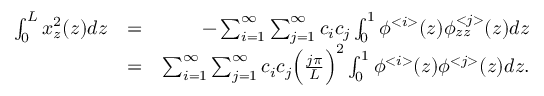Convert formula to latex. <formula><loc_0><loc_0><loc_500><loc_500>\begin{array} { r l r } { \int _ { 0 } ^ { L } x _ { z } ^ { 2 } ( z ) d z } & { = } & { - \sum _ { i = 1 } ^ { \infty } \sum _ { j = 1 } ^ { \infty } c _ { i } c _ { j } \int _ { 0 } ^ { 1 } \phi ^ { < i > } ( z ) \phi _ { z z } ^ { < j > } ( z ) d z } \\ & { = } & { \sum _ { i = 1 } ^ { \infty } \sum _ { j = 1 } ^ { \infty } c _ { i } c _ { j } \left ( \frac { j \pi } { L } \right ) ^ { 2 } \int _ { 0 } ^ { 1 } \phi ^ { < i > } ( z ) \phi ^ { < j > } ( z ) d z . } \end{array}</formula> 